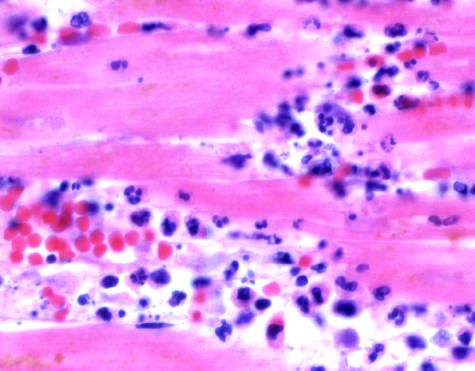do the photomicrographs show an inflammatory reaction in the myocardium after ischemic necrosis infarction?
Answer the question using a single word or phrase. Yes 